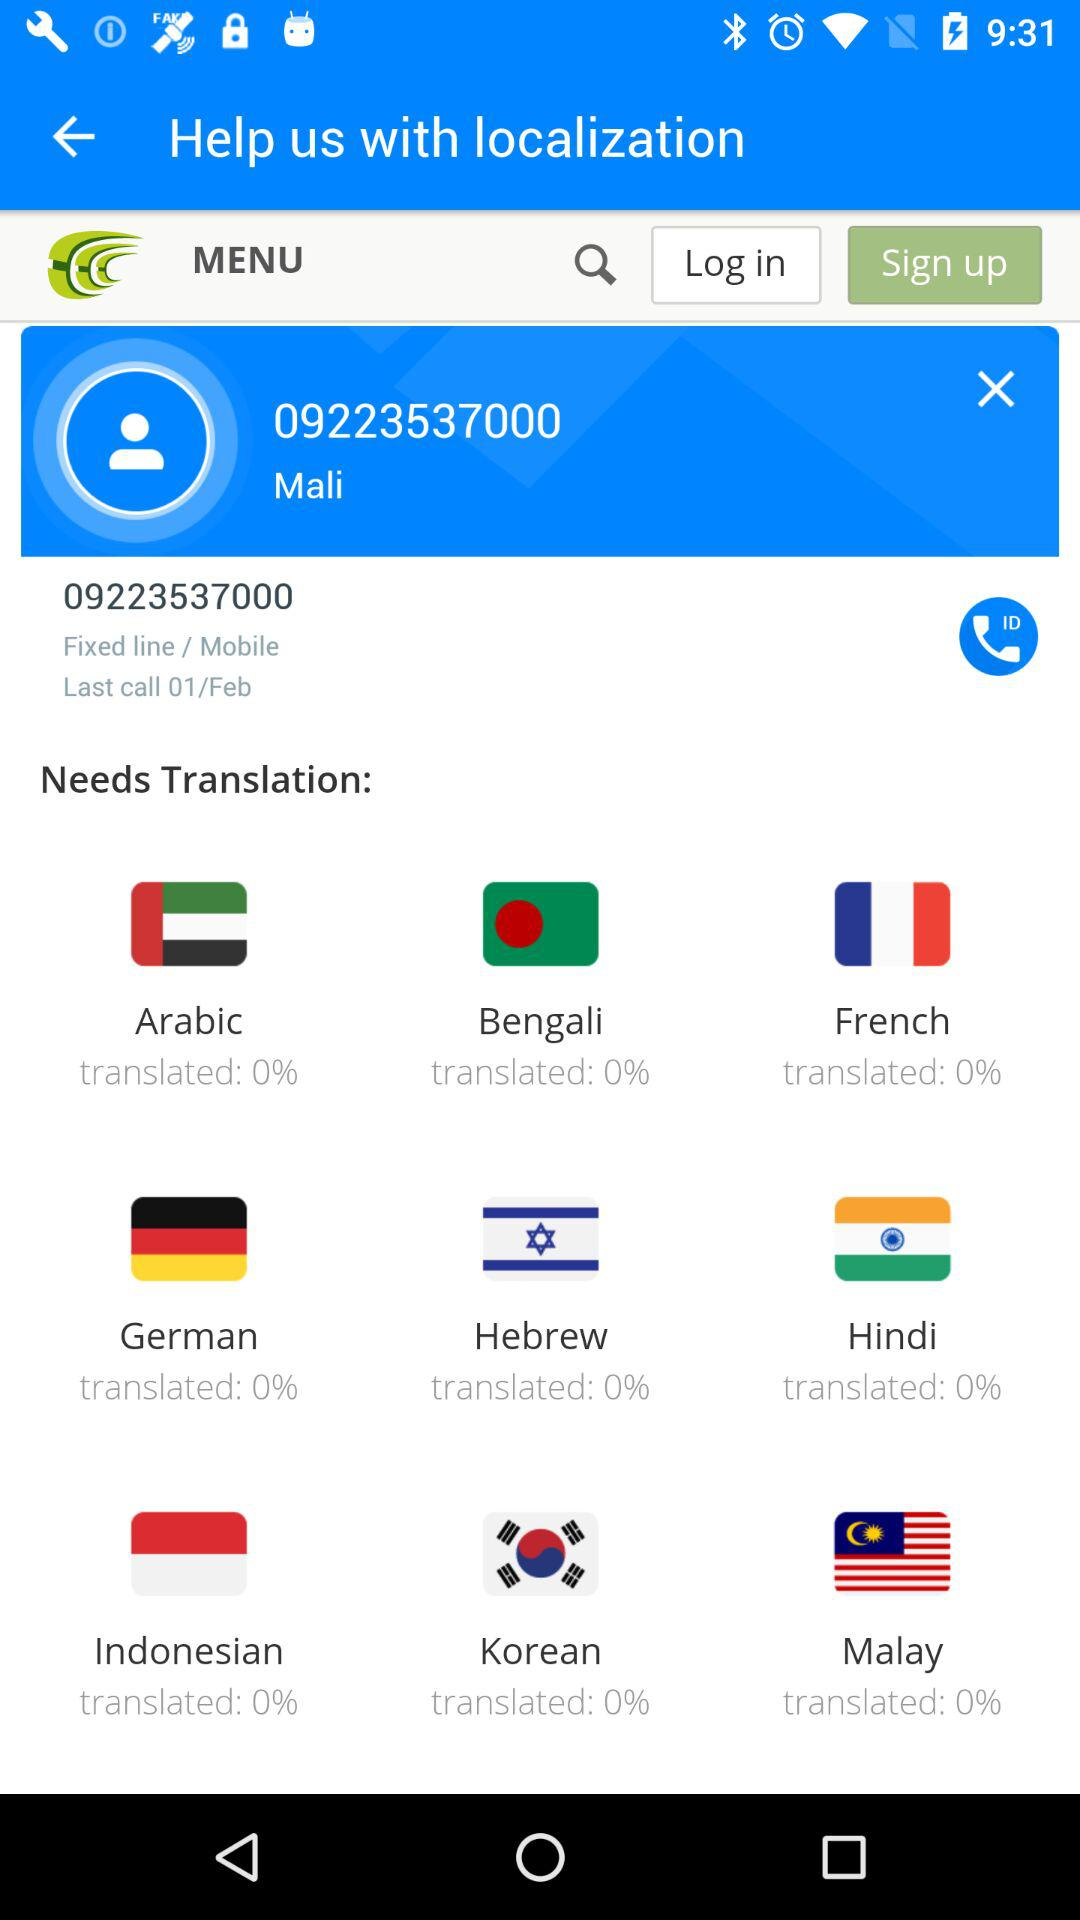What is the mobile number of mali? The mobile number of mali is 09223537000. 